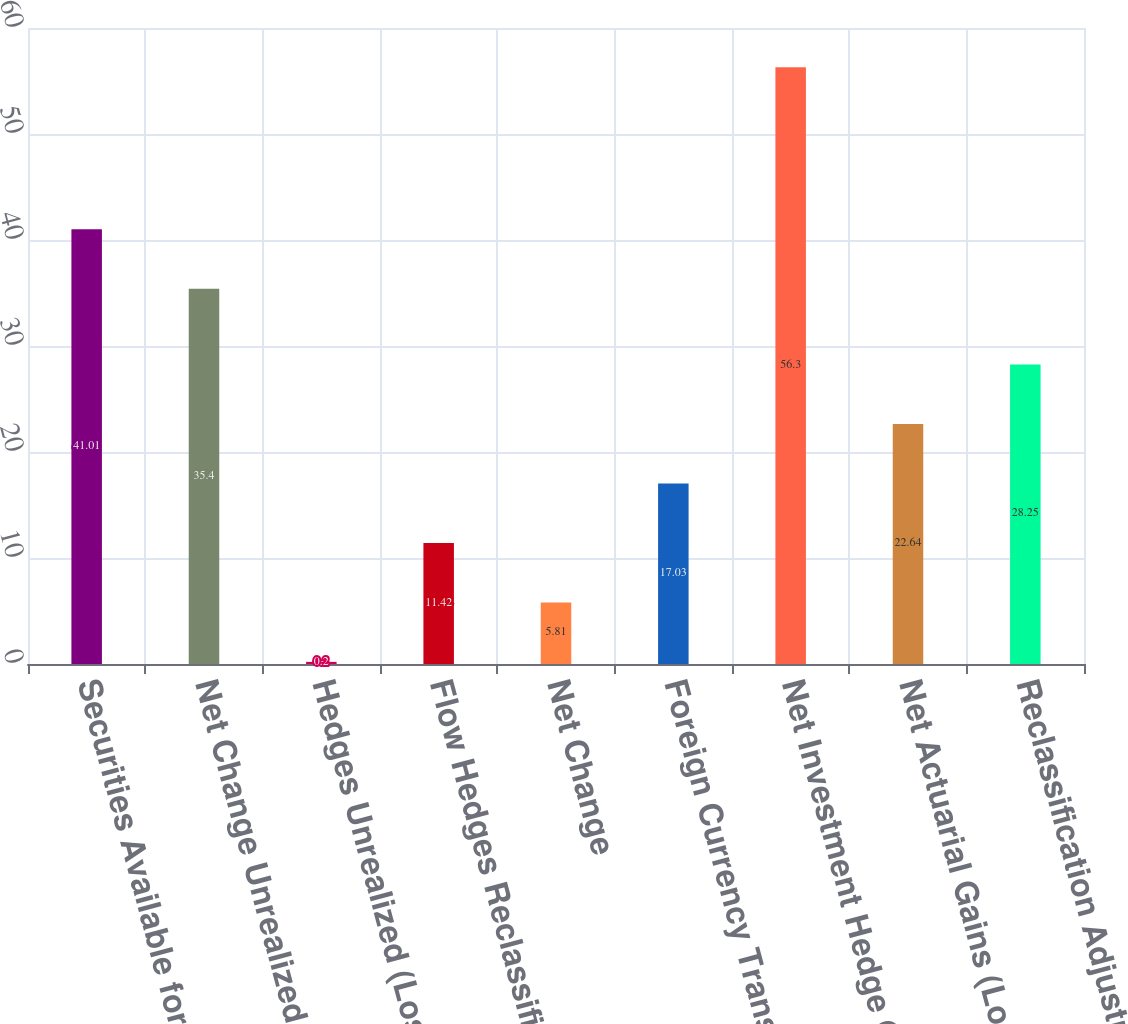<chart> <loc_0><loc_0><loc_500><loc_500><bar_chart><fcel>Securities Available for Sale<fcel>Net Change Unrealized (Losses)<fcel>Hedges Unrealized (Losses)<fcel>Flow Hedges Reclassification<fcel>Net Change<fcel>Foreign Currency Translation<fcel>Net Investment Hedge Gains<fcel>Net Actuarial Gains (Losses)<fcel>Reclassification Adjustment<nl><fcel>41.01<fcel>35.4<fcel>0.2<fcel>11.42<fcel>5.81<fcel>17.03<fcel>56.3<fcel>22.64<fcel>28.25<nl></chart> 